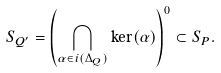Convert formula to latex. <formula><loc_0><loc_0><loc_500><loc_500>S _ { Q ^ { \prime } } = \left ( \bigcap _ { \alpha \in i ( \Delta _ { Q } ) } \ker ( \alpha ) \right ) ^ { 0 } \subset S _ { P } .</formula> 